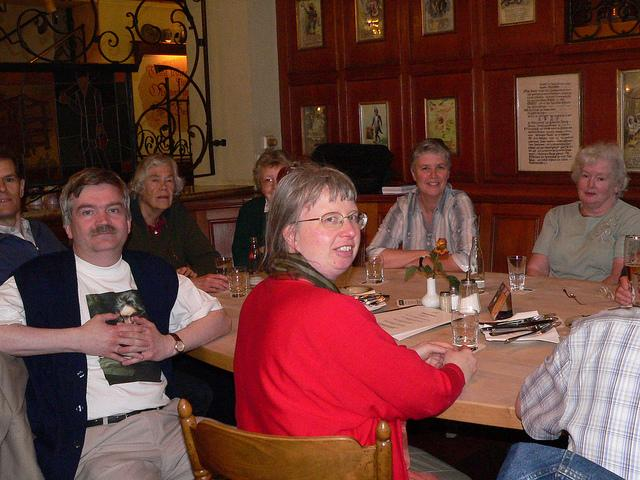What age class do most people here belong to?

Choices:
A) middle age
B) seniors
C) juniors
D) youth seniors 